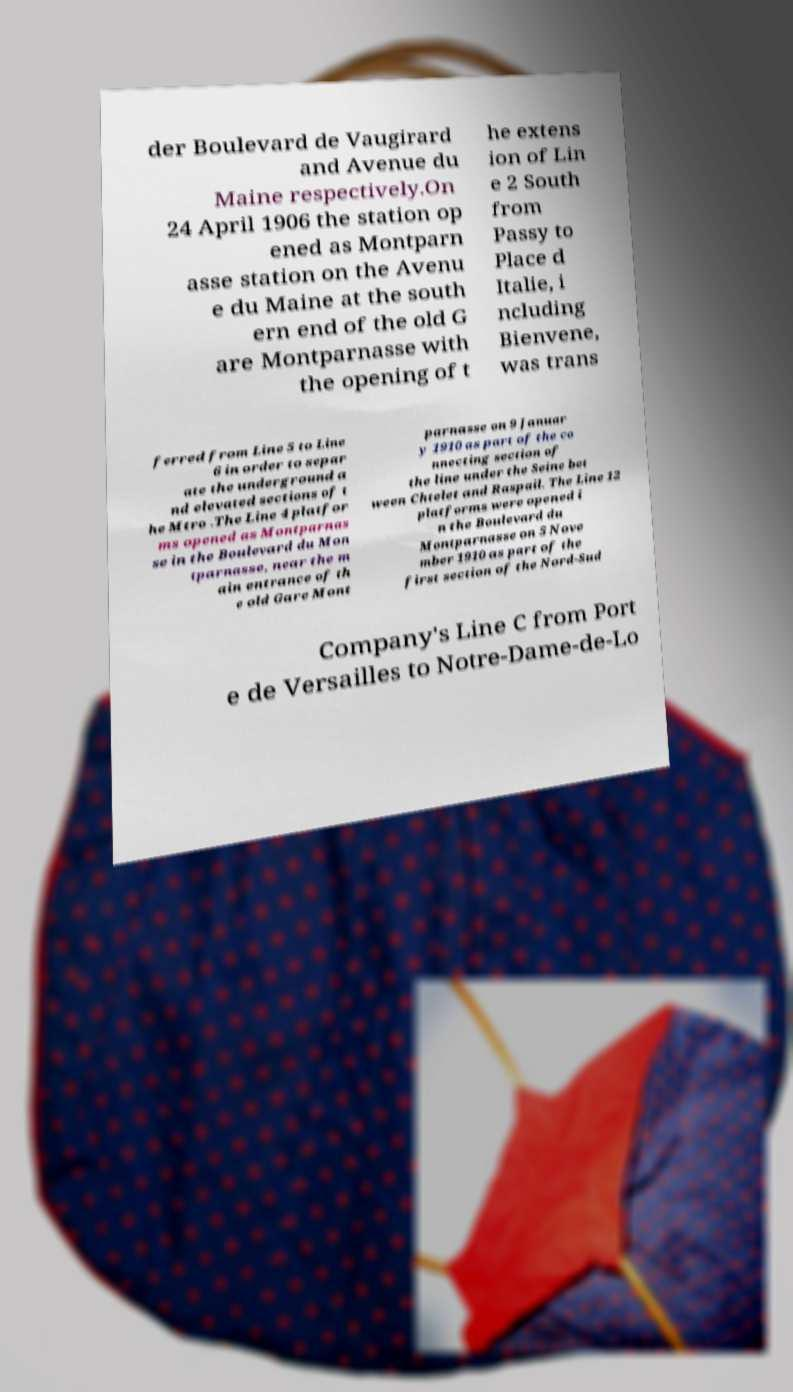Can you accurately transcribe the text from the provided image for me? der Boulevard de Vaugirard and Avenue du Maine respectively.On 24 April 1906 the station op ened as Montparn asse station on the Avenu e du Maine at the south ern end of the old G are Montparnasse with the opening of t he extens ion of Lin e 2 South from Passy to Place d Italie, i ncluding Bienvene, was trans ferred from Line 5 to Line 6 in order to separ ate the underground a nd elevated sections of t he Mtro .The Line 4 platfor ms opened as Montparnas se in the Boulevard du Mon tparnasse, near the m ain entrance of th e old Gare Mont parnasse on 9 Januar y 1910 as part of the co nnecting section of the line under the Seine bet ween Chtelet and Raspail. The Line 12 platforms were opened i n the Boulevard du Montparnasse on 5 Nove mber 1910 as part of the first section of the Nord-Sud Company's Line C from Port e de Versailles to Notre-Dame-de-Lo 